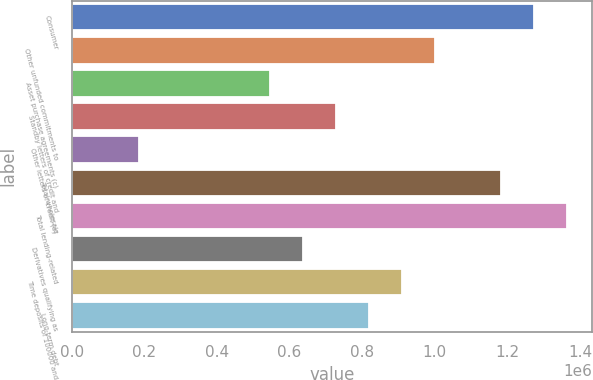<chart> <loc_0><loc_0><loc_500><loc_500><bar_chart><fcel>Consumer<fcel>Other unfunded commitments to<fcel>Asset purchase agreements (c)<fcel>Standby letters of credit and<fcel>Other letters of credit (a)<fcel>Total wholesale<fcel>Total lending-related<fcel>Derivatives qualifying as<fcel>Time deposits of 100000 and<fcel>Long-term debt<nl><fcel>1.27374e+06<fcel>1.00138e+06<fcel>547454<fcel>729024<fcel>184313<fcel>1.18295e+06<fcel>1.36452e+06<fcel>638239<fcel>910595<fcel>819810<nl></chart> 